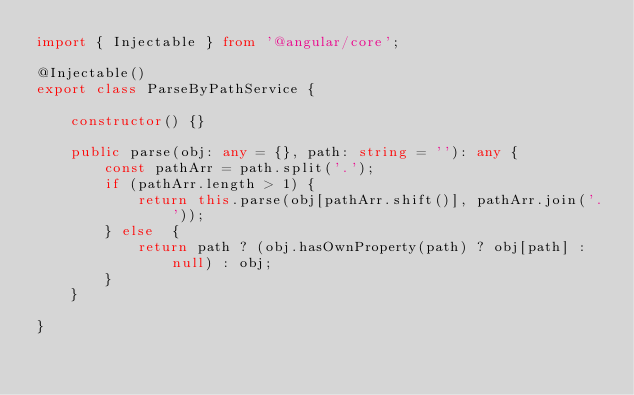<code> <loc_0><loc_0><loc_500><loc_500><_TypeScript_>import { Injectable } from '@angular/core';

@Injectable()
export class ParseByPathService {

    constructor() {}

    public parse(obj: any = {}, path: string = ''): any {
        const pathArr = path.split('.');
        if (pathArr.length > 1) {
            return this.parse(obj[pathArr.shift()], pathArr.join('.'));
        } else  {
            return path ? (obj.hasOwnProperty(path) ? obj[path] : null) : obj;
        }
    }

}
</code> 